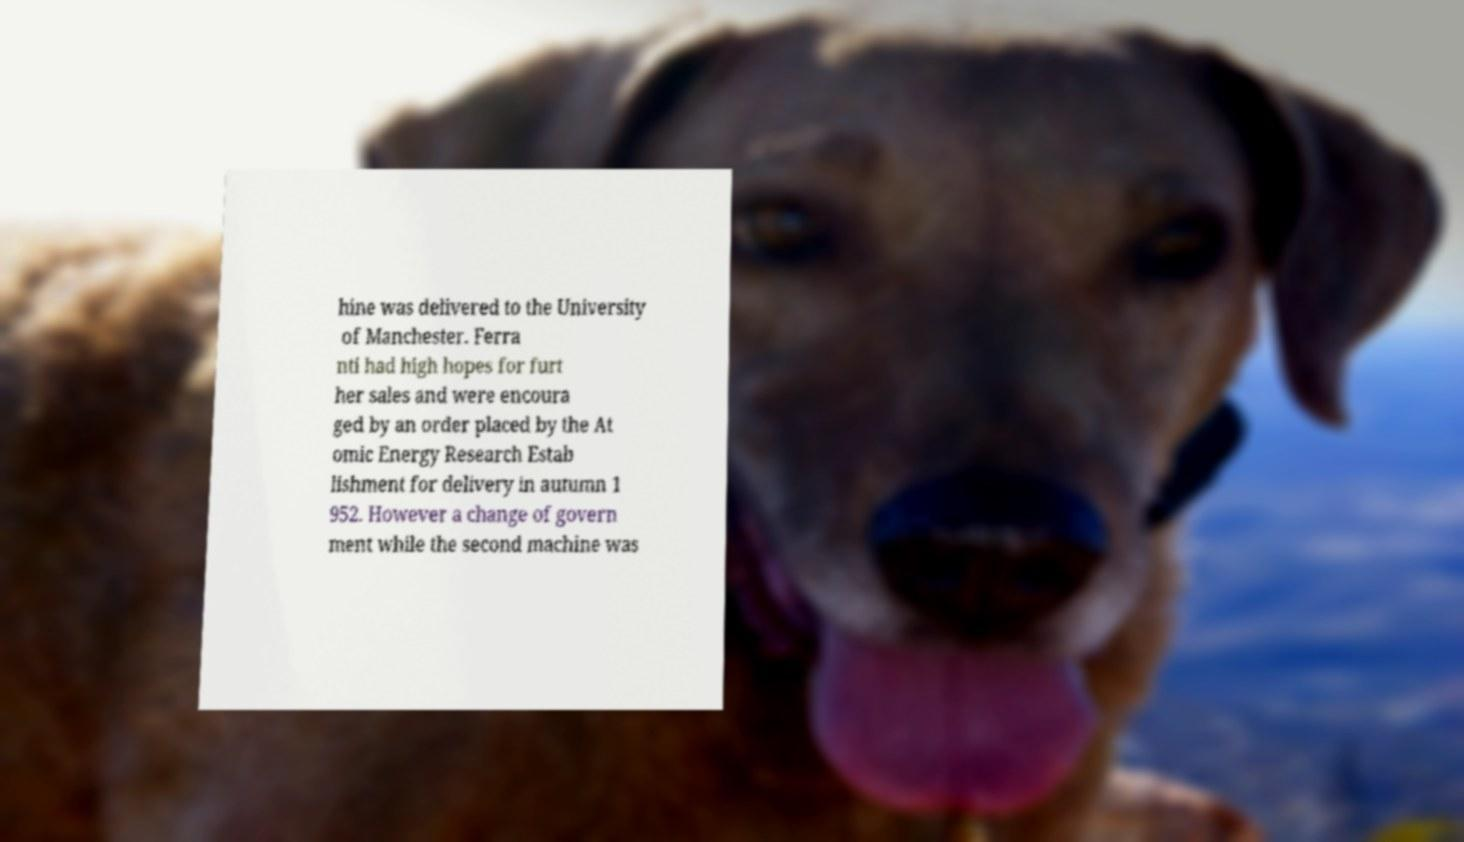Can you accurately transcribe the text from the provided image for me? hine was delivered to the University of Manchester. Ferra nti had high hopes for furt her sales and were encoura ged by an order placed by the At omic Energy Research Estab lishment for delivery in autumn 1 952. However a change of govern ment while the second machine was 